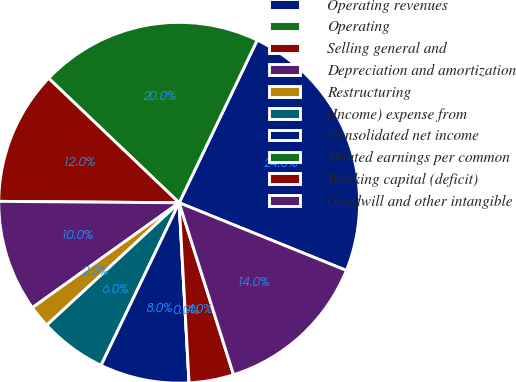Convert chart to OTSL. <chart><loc_0><loc_0><loc_500><loc_500><pie_chart><fcel>Operating revenues<fcel>Operating<fcel>Selling general and<fcel>Depreciation and amortization<fcel>Restructuring<fcel>(Income) expense from<fcel>Consolidated net income<fcel>Diluted earnings per common<fcel>Working capital (deficit)<fcel>Goodwill and other intangible<nl><fcel>24.0%<fcel>20.0%<fcel>12.0%<fcel>10.0%<fcel>2.0%<fcel>6.0%<fcel>8.0%<fcel>0.0%<fcel>4.0%<fcel>14.0%<nl></chart> 